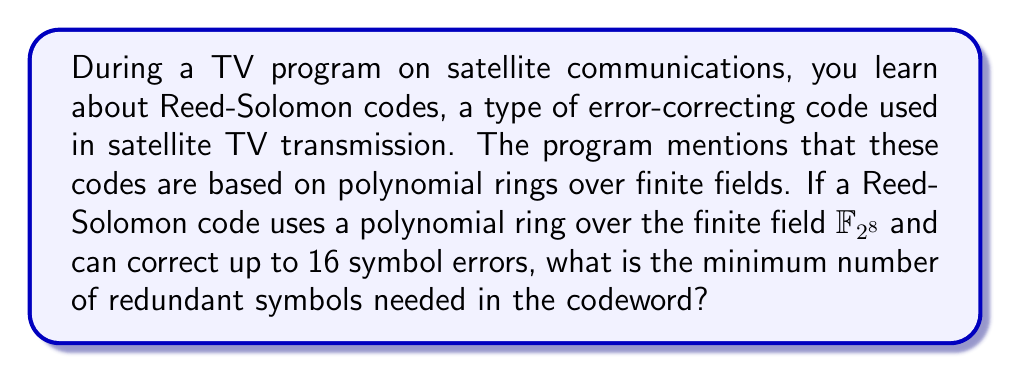Provide a solution to this math problem. Let's approach this step-by-step:

1) Reed-Solomon codes are based on polynomial evaluation. They work by encoding the message as coefficients of a polynomial.

2) The number of errors a Reed-Solomon code can correct is related to the number of redundant symbols. Specifically, if the code can correct $t$ errors, it needs $2t$ redundant symbols.

3) In this case, we're told the code can correct up to 16 symbol errors. So, $t = 16$.

4) Using the formula from step 2:
   Number of redundant symbols $= 2t = 2 \times 16 = 32$

5) It's worth noting that each symbol in this code is an element of $\mathbb{F}_{2^8}$, which means each symbol is 8 bits long. However, this doesn't affect the number of redundant symbols needed.

6) The polynomial used for encoding would be of degree 31 (one less than the number of redundant symbols), and would be defined over $\mathbb{F}_{2^8}[x]$, the ring of polynomials with coefficients in $\mathbb{F}_{2^8}$.

Therefore, the minimum number of redundant symbols needed is 32.
Answer: 32 